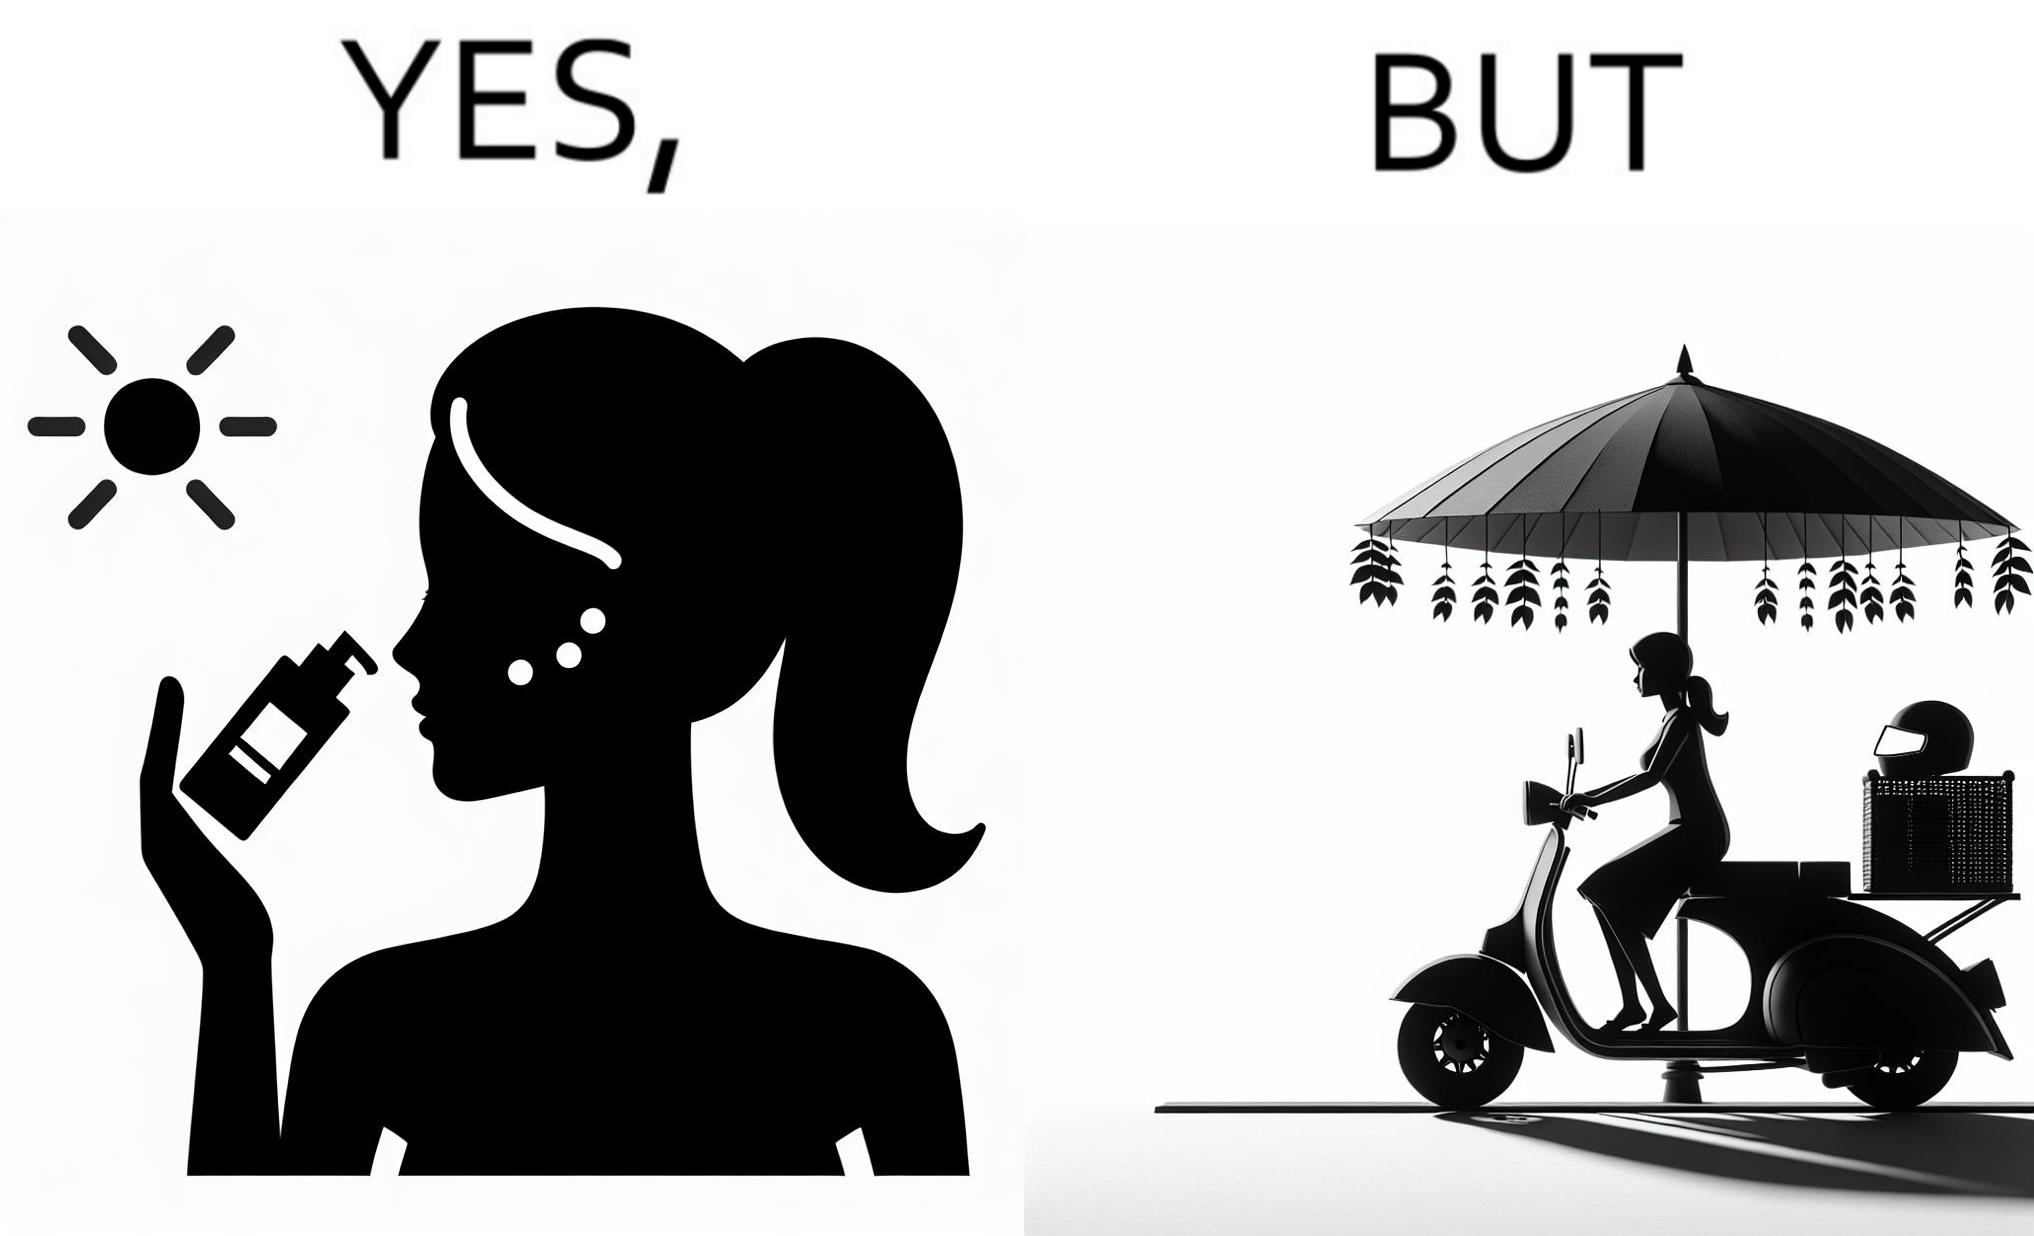What does this image depict? The image is funny because while the woman is concerned about protection from the sun rays, she is not concerned about her safety while riding a scooter. 